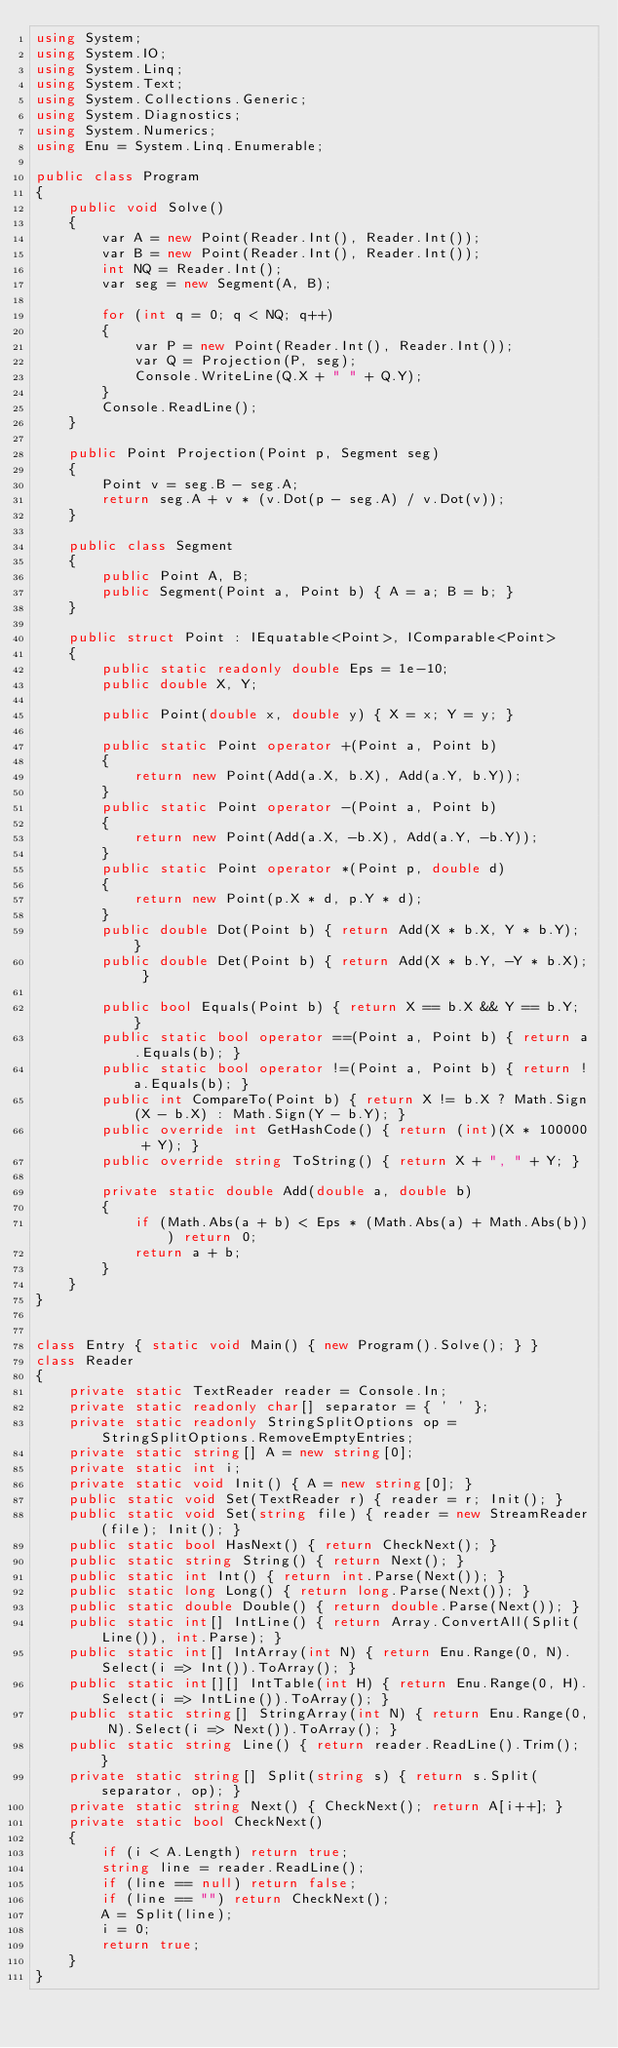Convert code to text. <code><loc_0><loc_0><loc_500><loc_500><_C#_>using System;
using System.IO;
using System.Linq;
using System.Text;
using System.Collections.Generic;
using System.Diagnostics;
using System.Numerics;
using Enu = System.Linq.Enumerable;

public class Program
{
    public void Solve()
    {
        var A = new Point(Reader.Int(), Reader.Int());
        var B = new Point(Reader.Int(), Reader.Int());
        int NQ = Reader.Int();
        var seg = new Segment(A, B);

        for (int q = 0; q < NQ; q++)
        {
            var P = new Point(Reader.Int(), Reader.Int());
            var Q = Projection(P, seg);
            Console.WriteLine(Q.X + " " + Q.Y);
        }
        Console.ReadLine();
    }

    public Point Projection(Point p, Segment seg)
    {
        Point v = seg.B - seg.A;
        return seg.A + v * (v.Dot(p - seg.A) / v.Dot(v));
    }

    public class Segment
    {
        public Point A, B;
        public Segment(Point a, Point b) { A = a; B = b; }
    }

    public struct Point : IEquatable<Point>, IComparable<Point>
    {
        public static readonly double Eps = 1e-10;
        public double X, Y;

        public Point(double x, double y) { X = x; Y = y; }

        public static Point operator +(Point a, Point b)
        {
            return new Point(Add(a.X, b.X), Add(a.Y, b.Y));
        }
        public static Point operator -(Point a, Point b)
        {
            return new Point(Add(a.X, -b.X), Add(a.Y, -b.Y));
        }
        public static Point operator *(Point p, double d)
        {
            return new Point(p.X * d, p.Y * d);
        }
        public double Dot(Point b) { return Add(X * b.X, Y * b.Y); }
        public double Det(Point b) { return Add(X * b.Y, -Y * b.X); }

        public bool Equals(Point b) { return X == b.X && Y == b.Y; }
        public static bool operator ==(Point a, Point b) { return a.Equals(b); }
        public static bool operator !=(Point a, Point b) { return !a.Equals(b); }
        public int CompareTo(Point b) { return X != b.X ? Math.Sign(X - b.X) : Math.Sign(Y - b.Y); }
        public override int GetHashCode() { return (int)(X * 100000 + Y); }
        public override string ToString() { return X + ", " + Y; }

        private static double Add(double a, double b)
        {
            if (Math.Abs(a + b) < Eps * (Math.Abs(a) + Math.Abs(b))) return 0;
            return a + b;
        }
    }
}


class Entry { static void Main() { new Program().Solve(); } }
class Reader
{
    private static TextReader reader = Console.In;
    private static readonly char[] separator = { ' ' };
    private static readonly StringSplitOptions op = StringSplitOptions.RemoveEmptyEntries;
    private static string[] A = new string[0];
    private static int i;
    private static void Init() { A = new string[0]; }
    public static void Set(TextReader r) { reader = r; Init(); }
    public static void Set(string file) { reader = new StreamReader(file); Init(); }
    public static bool HasNext() { return CheckNext(); }
    public static string String() { return Next(); }
    public static int Int() { return int.Parse(Next()); }
    public static long Long() { return long.Parse(Next()); }
    public static double Double() { return double.Parse(Next()); }
    public static int[] IntLine() { return Array.ConvertAll(Split(Line()), int.Parse); }
    public static int[] IntArray(int N) { return Enu.Range(0, N).Select(i => Int()).ToArray(); }
    public static int[][] IntTable(int H) { return Enu.Range(0, H).Select(i => IntLine()).ToArray(); }
    public static string[] StringArray(int N) { return Enu.Range(0, N).Select(i => Next()).ToArray(); }
    public static string Line() { return reader.ReadLine().Trim(); }
    private static string[] Split(string s) { return s.Split(separator, op); }
    private static string Next() { CheckNext(); return A[i++]; }
    private static bool CheckNext()
    {
        if (i < A.Length) return true;
        string line = reader.ReadLine();
        if (line == null) return false;
        if (line == "") return CheckNext();
        A = Split(line);
        i = 0;
        return true;
    }
}</code> 